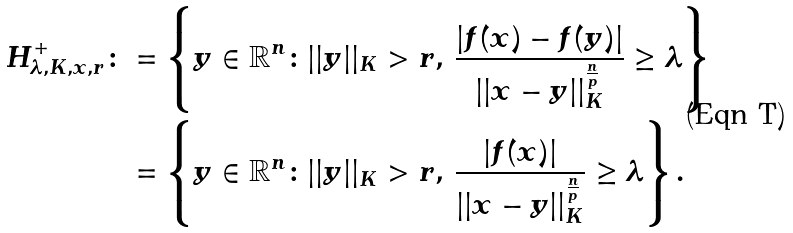Convert formula to latex. <formula><loc_0><loc_0><loc_500><loc_500>H _ { \lambda , K , x , r } ^ { + } \colon & = \left \{ y \in \mathbb { R } ^ { n } \colon | | y | | _ { K } > r , \, \frac { | f ( x ) - f ( y ) | } { | | x - y | | _ { K } ^ { \frac { n } { p } } } \geq \lambda \right \} \\ & = \left \{ y \in \mathbb { R } ^ { n } \colon | | y | | _ { K } > r , \, \frac { | f ( x ) | } { | | x - y | | _ { K } ^ { \frac { n } { p } } } \geq \lambda \right \} .</formula> 